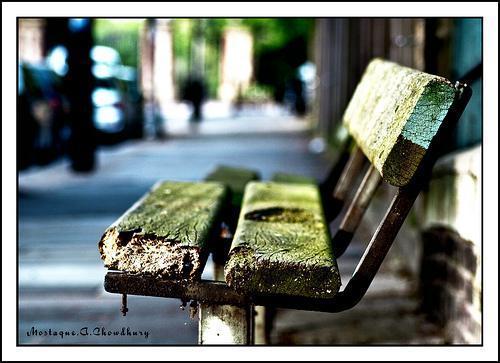How many benches?
Give a very brief answer. 1. 